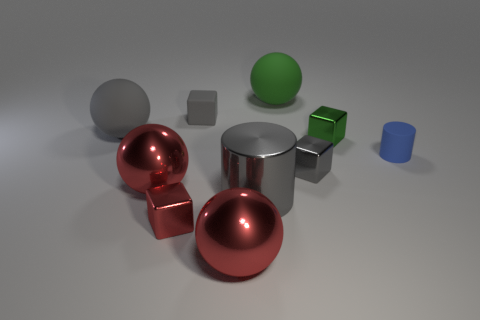Subtract 1 balls. How many balls are left? 3 Subtract all cylinders. How many objects are left? 8 Add 3 big red metallic objects. How many big red metallic objects exist? 5 Subtract 1 red balls. How many objects are left? 9 Subtract all blue things. Subtract all small gray matte blocks. How many objects are left? 8 Add 7 large gray metallic objects. How many large gray metallic objects are left? 8 